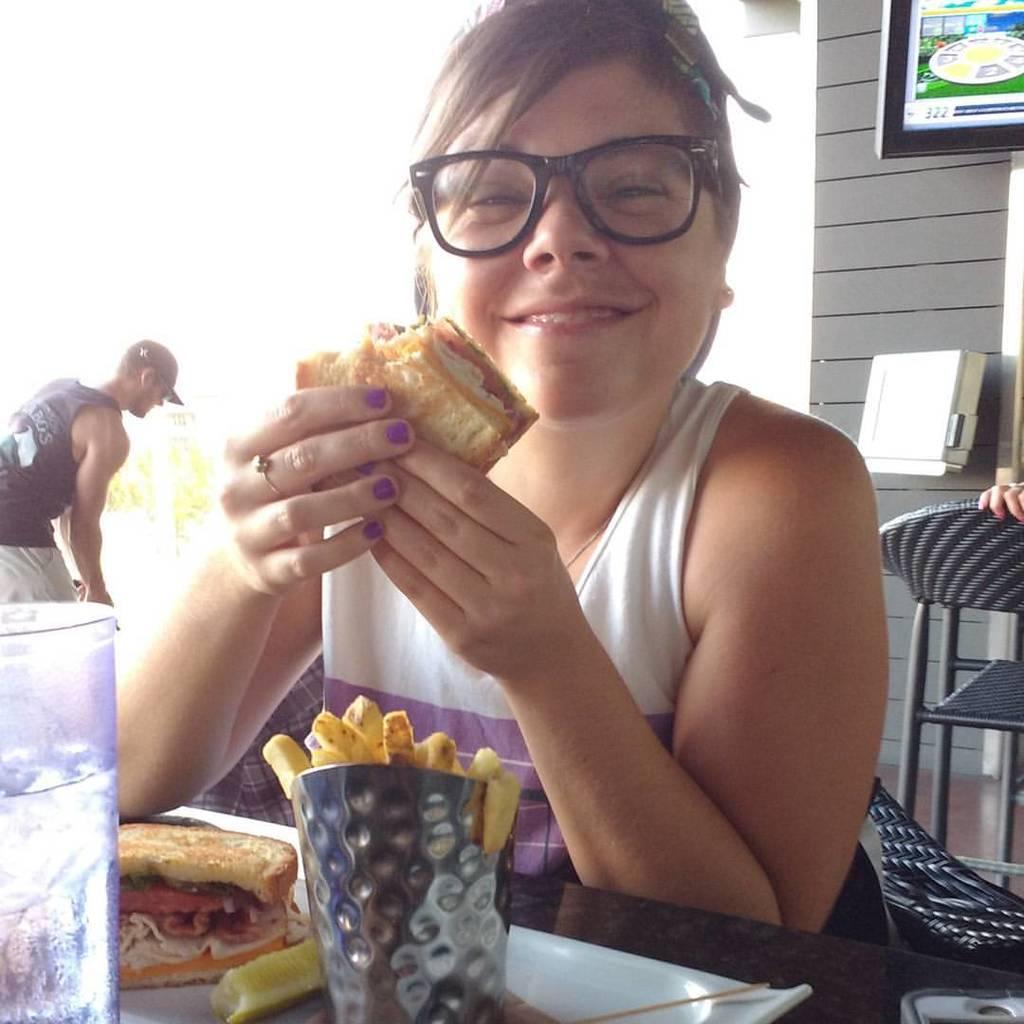In one or two sentences, can you explain what this image depicts? In the center of the image we can see a lady is sitting on a chair and smiling and holding a food and wearing a dress, spectacles. In-front of her we can see a table. On the table we can see a plate which contains food items, a glass of water. In the background of the image we can see the wall, stool, screen, box, trees and a person is bending and holding an object and wearing a cap, dress. 